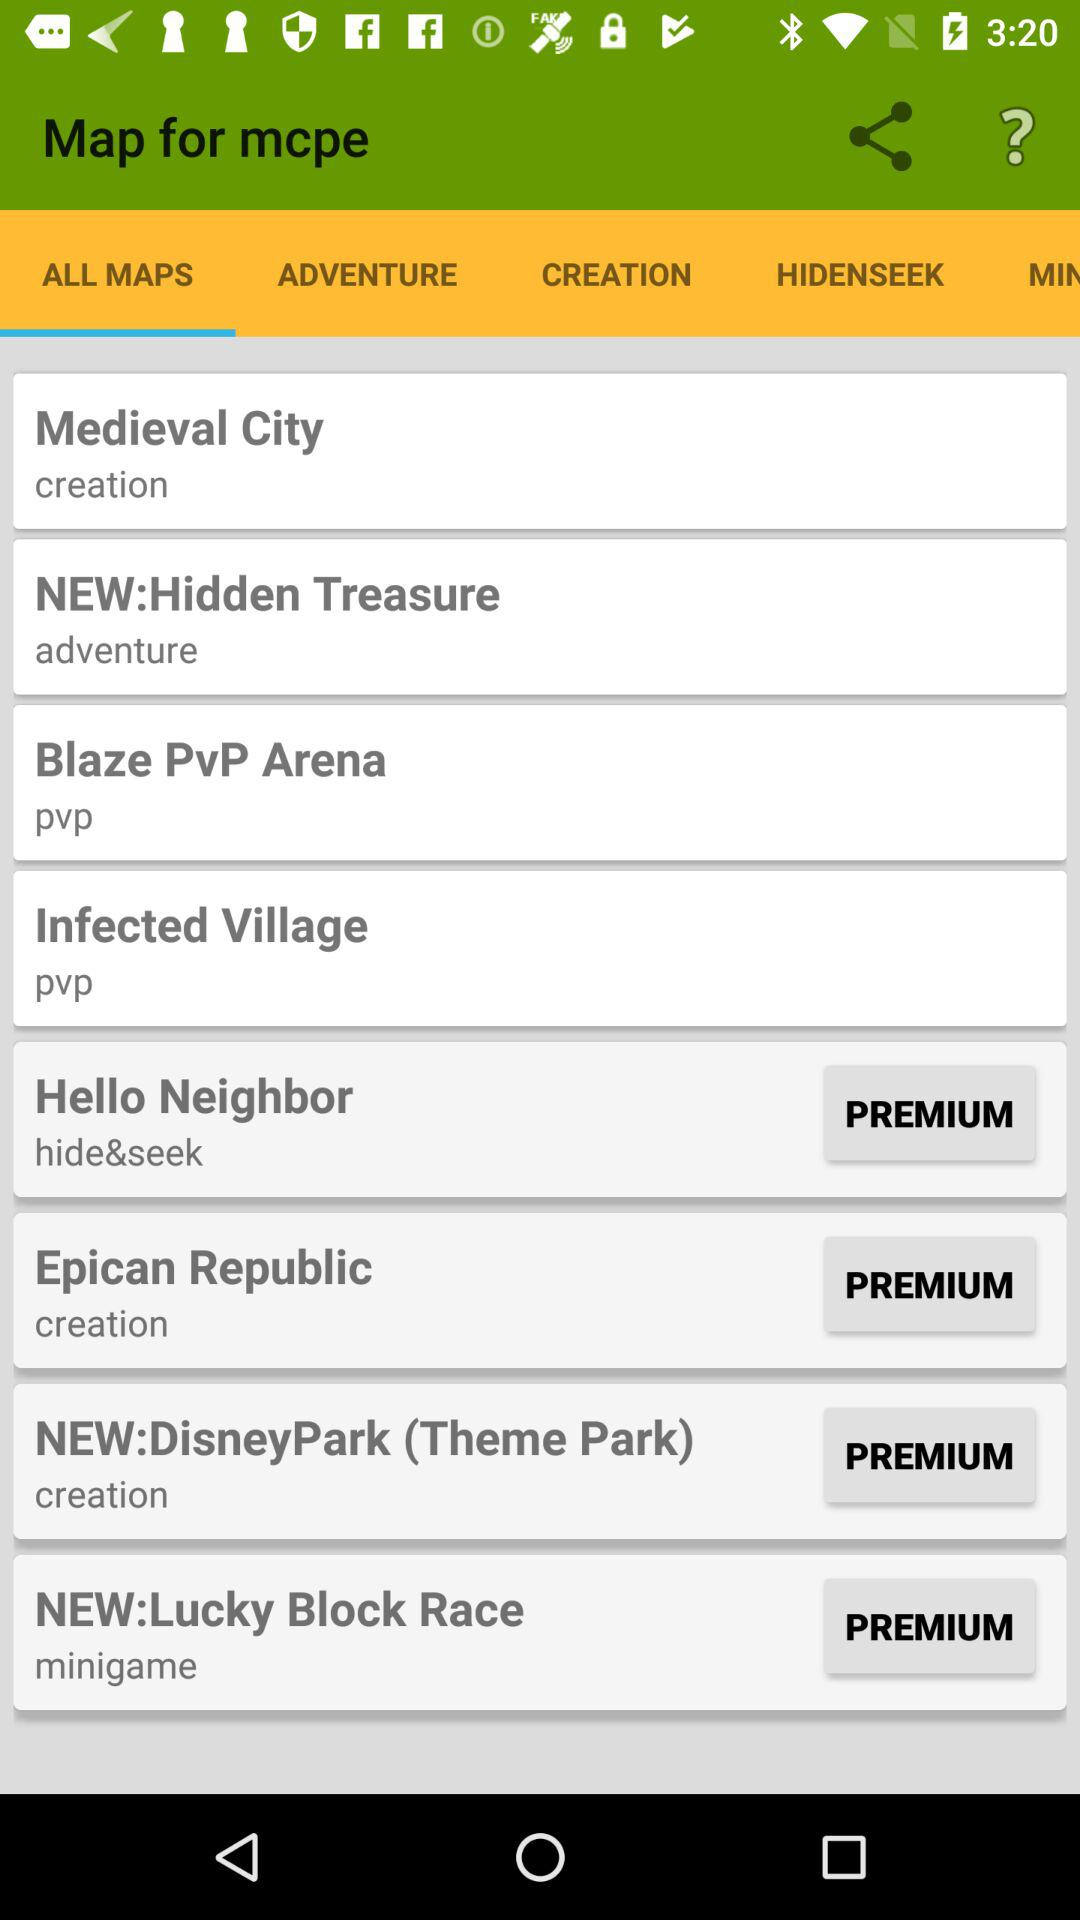With which subscription is "Hello Neighbor" available? "Hello Neighbor" is available with the premium subscription. 